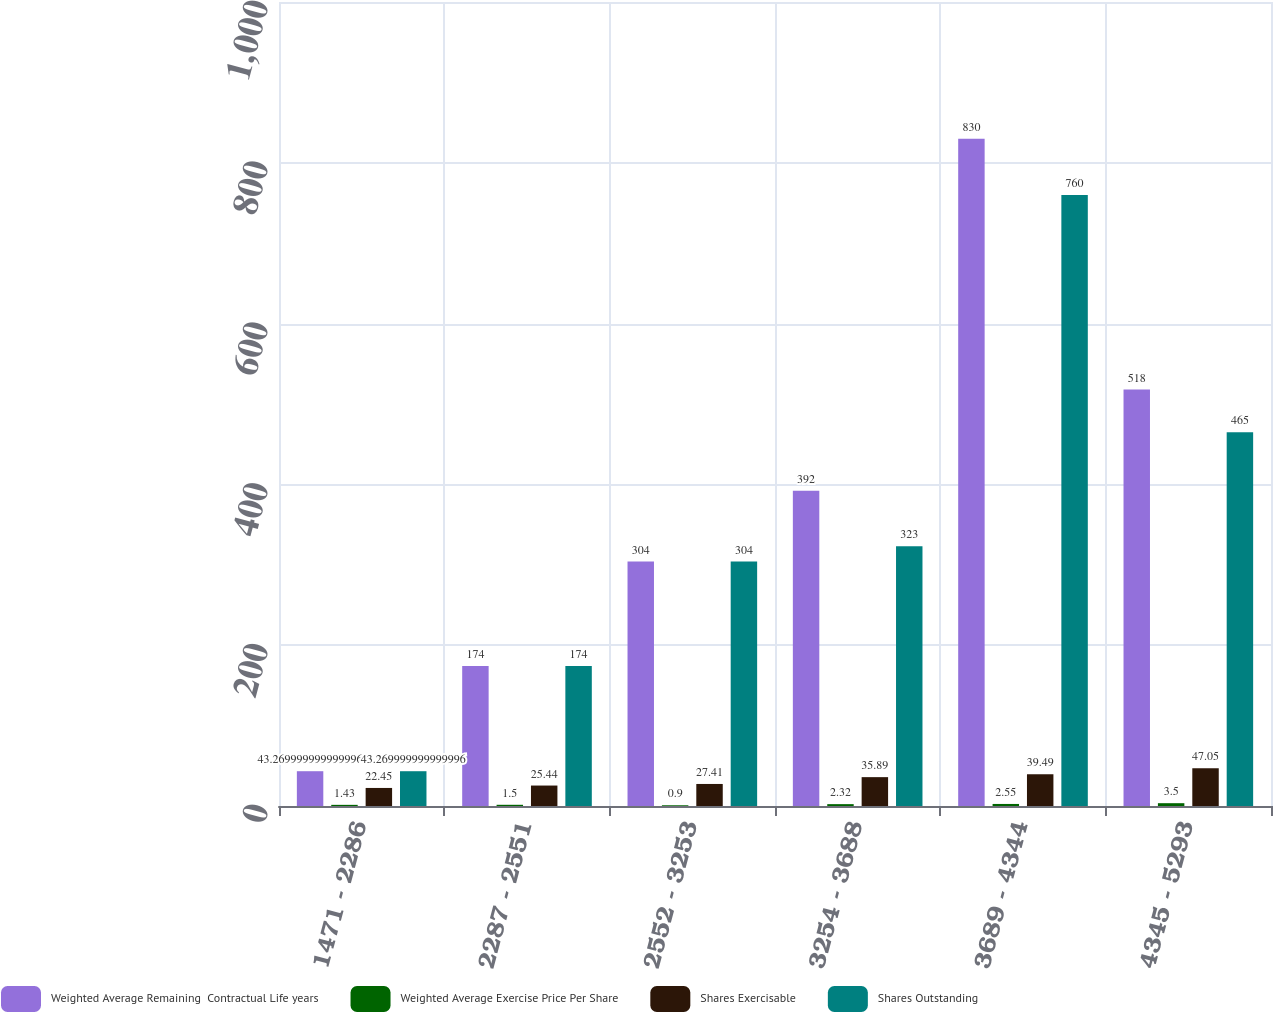Convert chart. <chart><loc_0><loc_0><loc_500><loc_500><stacked_bar_chart><ecel><fcel>1471 - 2286<fcel>2287 - 2551<fcel>2552 - 3253<fcel>3254 - 3688<fcel>3689 - 4344<fcel>4345 - 5293<nl><fcel>Weighted Average Remaining  Contractual Life years<fcel>43.27<fcel>174<fcel>304<fcel>392<fcel>830<fcel>518<nl><fcel>Weighted Average Exercise Price Per Share<fcel>1.43<fcel>1.5<fcel>0.9<fcel>2.32<fcel>2.55<fcel>3.5<nl><fcel>Shares Exercisable<fcel>22.45<fcel>25.44<fcel>27.41<fcel>35.89<fcel>39.49<fcel>47.05<nl><fcel>Shares Outstanding<fcel>43.27<fcel>174<fcel>304<fcel>323<fcel>760<fcel>465<nl></chart> 